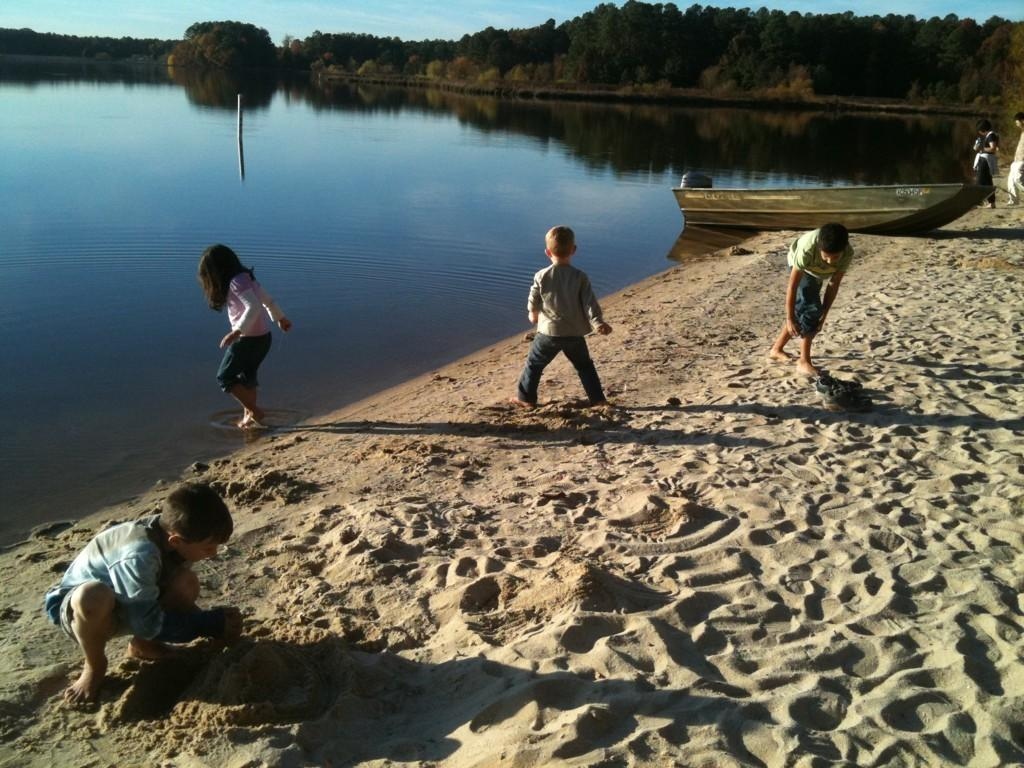Who is present in the image? There are children in the image. What type of surface can be seen in the image? There is sand in the image. What type of vehicle is in the image? There is a boat in the image. What can be seen near the boat? There is water visible in the image. What type of vegetation is in the image? There are trees in the image. What is visible in the background of the image? The sky is visible in the background of the image. What type of crime is being committed in the image? There is no crime being committed in the image; it features children, a boat, sand, water, trees, and a sky. What type of grain is being harvested in the image? There is no grain being harvested in the image; it features children, a boat, sand, water, trees, and a sky. 